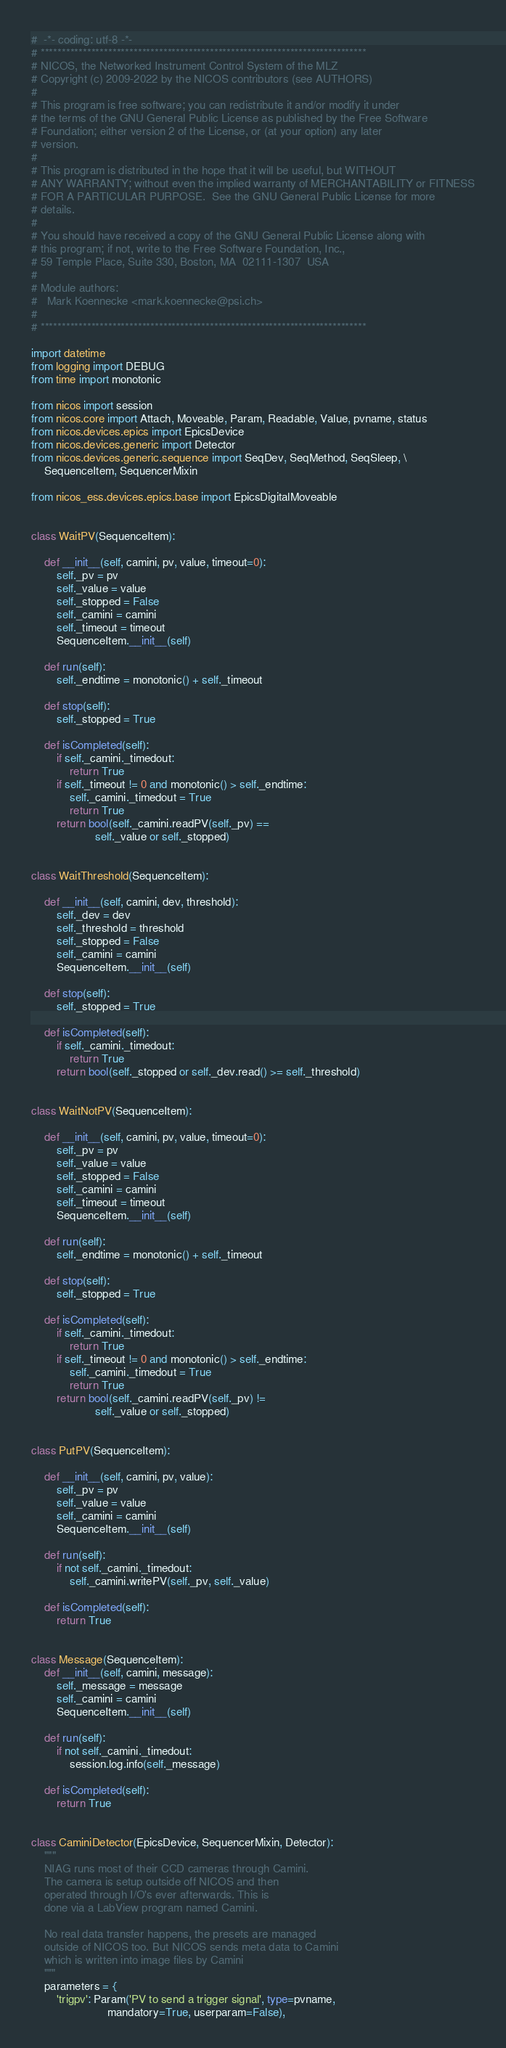Convert code to text. <code><loc_0><loc_0><loc_500><loc_500><_Python_>#  -*- coding: utf-8 -*-
# *****************************************************************************
# NICOS, the Networked Instrument Control System of the MLZ
# Copyright (c) 2009-2022 by the NICOS contributors (see AUTHORS)
#
# This program is free software; you can redistribute it and/or modify it under
# the terms of the GNU General Public License as published by the Free Software
# Foundation; either version 2 of the License, or (at your option) any later
# version.
#
# This program is distributed in the hope that it will be useful, but WITHOUT
# ANY WARRANTY; without even the implied warranty of MERCHANTABILITY or FITNESS
# FOR A PARTICULAR PURPOSE.  See the GNU General Public License for more
# details.
#
# You should have received a copy of the GNU General Public License along with
# this program; if not, write to the Free Software Foundation, Inc.,
# 59 Temple Place, Suite 330, Boston, MA  02111-1307  USA
#
# Module authors:
#   Mark Koennecke <mark.koennecke@psi.ch>
#
# *****************************************************************************

import datetime
from logging import DEBUG
from time import monotonic

from nicos import session
from nicos.core import Attach, Moveable, Param, Readable, Value, pvname, status
from nicos.devices.epics import EpicsDevice
from nicos.devices.generic import Detector
from nicos.devices.generic.sequence import SeqDev, SeqMethod, SeqSleep, \
    SequenceItem, SequencerMixin

from nicos_ess.devices.epics.base import EpicsDigitalMoveable


class WaitPV(SequenceItem):

    def __init__(self, camini, pv, value, timeout=0):
        self._pv = pv
        self._value = value
        self._stopped = False
        self._camini = camini
        self._timeout = timeout
        SequenceItem.__init__(self)

    def run(self):
        self._endtime = monotonic() + self._timeout

    def stop(self):
        self._stopped = True

    def isCompleted(self):
        if self._camini._timedout:
            return True
        if self._timeout != 0 and monotonic() > self._endtime:
            self._camini._timedout = True
            return True
        return bool(self._camini.readPV(self._pv) ==
                    self._value or self._stopped)


class WaitThreshold(SequenceItem):

    def __init__(self, camini, dev, threshold):
        self._dev = dev
        self._threshold = threshold
        self._stopped = False
        self._camini = camini
        SequenceItem.__init__(self)

    def stop(self):
        self._stopped = True

    def isCompleted(self):
        if self._camini._timedout:
            return True
        return bool(self._stopped or self._dev.read() >= self._threshold)


class WaitNotPV(SequenceItem):

    def __init__(self, camini, pv, value, timeout=0):
        self._pv = pv
        self._value = value
        self._stopped = False
        self._camini = camini
        self._timeout = timeout
        SequenceItem.__init__(self)

    def run(self):
        self._endtime = monotonic() + self._timeout

    def stop(self):
        self._stopped = True

    def isCompleted(self):
        if self._camini._timedout:
            return True
        if self._timeout != 0 and monotonic() > self._endtime:
            self._camini._timedout = True
            return True
        return bool(self._camini.readPV(self._pv) !=
                    self._value or self._stopped)


class PutPV(SequenceItem):

    def __init__(self, camini, pv, value):
        self._pv = pv
        self._value = value
        self._camini = camini
        SequenceItem.__init__(self)

    def run(self):
        if not self._camini._timedout:
            self._camini.writePV(self._pv, self._value)

    def isCompleted(self):
        return True


class Message(SequenceItem):
    def __init__(self, camini, message):
        self._message = message
        self._camini = camini
        SequenceItem.__init__(self)

    def run(self):
        if not self._camini._timedout:
            session.log.info(self._message)

    def isCompleted(self):
        return True


class CaminiDetector(EpicsDevice, SequencerMixin, Detector):
    """
    NIAG runs most of their CCD cameras through Camini.
    The camera is setup outside off NICOS and then
    operated through I/O's ever afterwards. This is
    done via a LabView program named Camini.

    No real data transfer happens, the presets are managed
    outside of NICOS too. But NICOS sends meta data to Camini
    which is written into image files by Camini
    """
    parameters = {
        'trigpv': Param('PV to send a trigger signal', type=pvname,
                        mandatory=True, userparam=False),</code> 